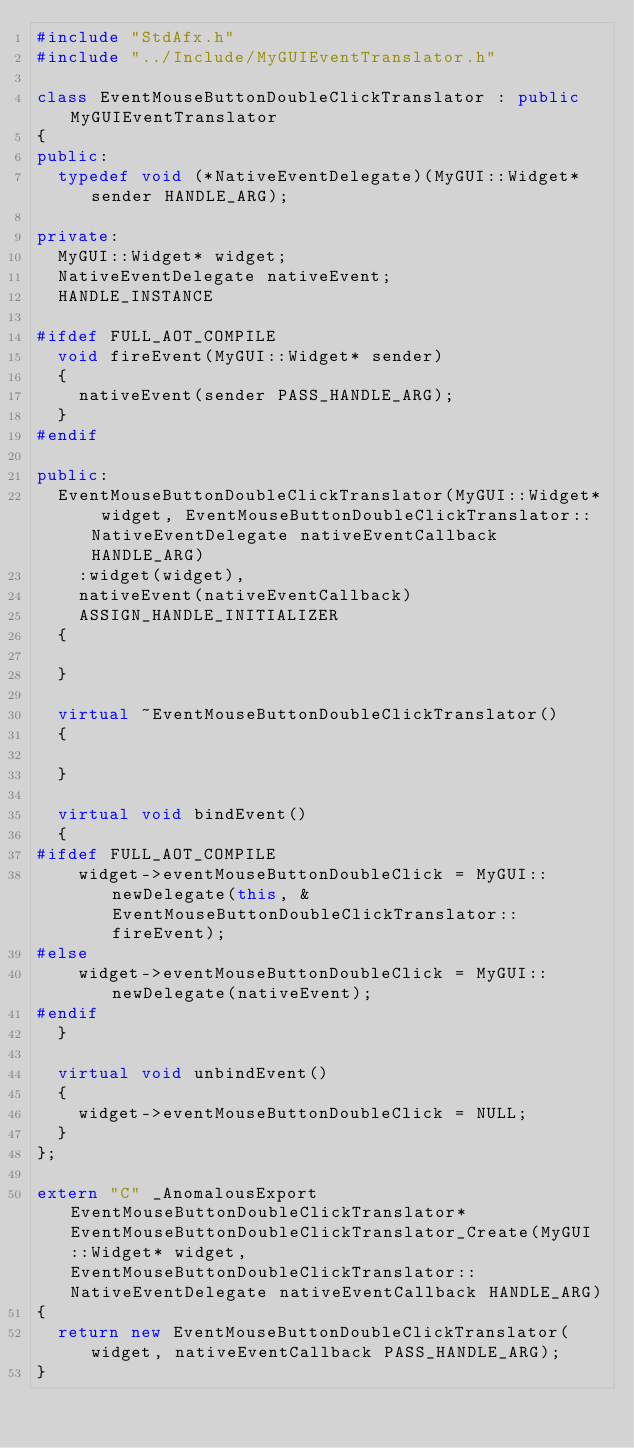Convert code to text. <code><loc_0><loc_0><loc_500><loc_500><_C++_>#include "StdAfx.h"
#include "../Include/MyGUIEventTranslator.h"

class EventMouseButtonDoubleClickTranslator : public MyGUIEventTranslator
{
public:
	typedef void (*NativeEventDelegate)(MyGUI::Widget* sender HANDLE_ARG);

private:
	MyGUI::Widget* widget;
	NativeEventDelegate nativeEvent;
	HANDLE_INSTANCE

#ifdef FULL_AOT_COMPILE
	void fireEvent(MyGUI::Widget* sender)
	{
		nativeEvent(sender PASS_HANDLE_ARG);
	}
#endif

public:
	EventMouseButtonDoubleClickTranslator(MyGUI::Widget* widget, EventMouseButtonDoubleClickTranslator::NativeEventDelegate nativeEventCallback HANDLE_ARG)
		:widget(widget),
		nativeEvent(nativeEventCallback)
		ASSIGN_HANDLE_INITIALIZER
	{

	}

	virtual ~EventMouseButtonDoubleClickTranslator()
	{

	}

	virtual void bindEvent()
	{
#ifdef FULL_AOT_COMPILE
		widget->eventMouseButtonDoubleClick = MyGUI::newDelegate(this, &EventMouseButtonDoubleClickTranslator::fireEvent);
#else
		widget->eventMouseButtonDoubleClick = MyGUI::newDelegate(nativeEvent);
#endif
	}

	virtual void unbindEvent()
	{
		widget->eventMouseButtonDoubleClick = NULL;
	}
};

extern "C" _AnomalousExport EventMouseButtonDoubleClickTranslator* EventMouseButtonDoubleClickTranslator_Create(MyGUI::Widget* widget, EventMouseButtonDoubleClickTranslator::NativeEventDelegate nativeEventCallback HANDLE_ARG)
{
	return new EventMouseButtonDoubleClickTranslator(widget, nativeEventCallback PASS_HANDLE_ARG);
}</code> 